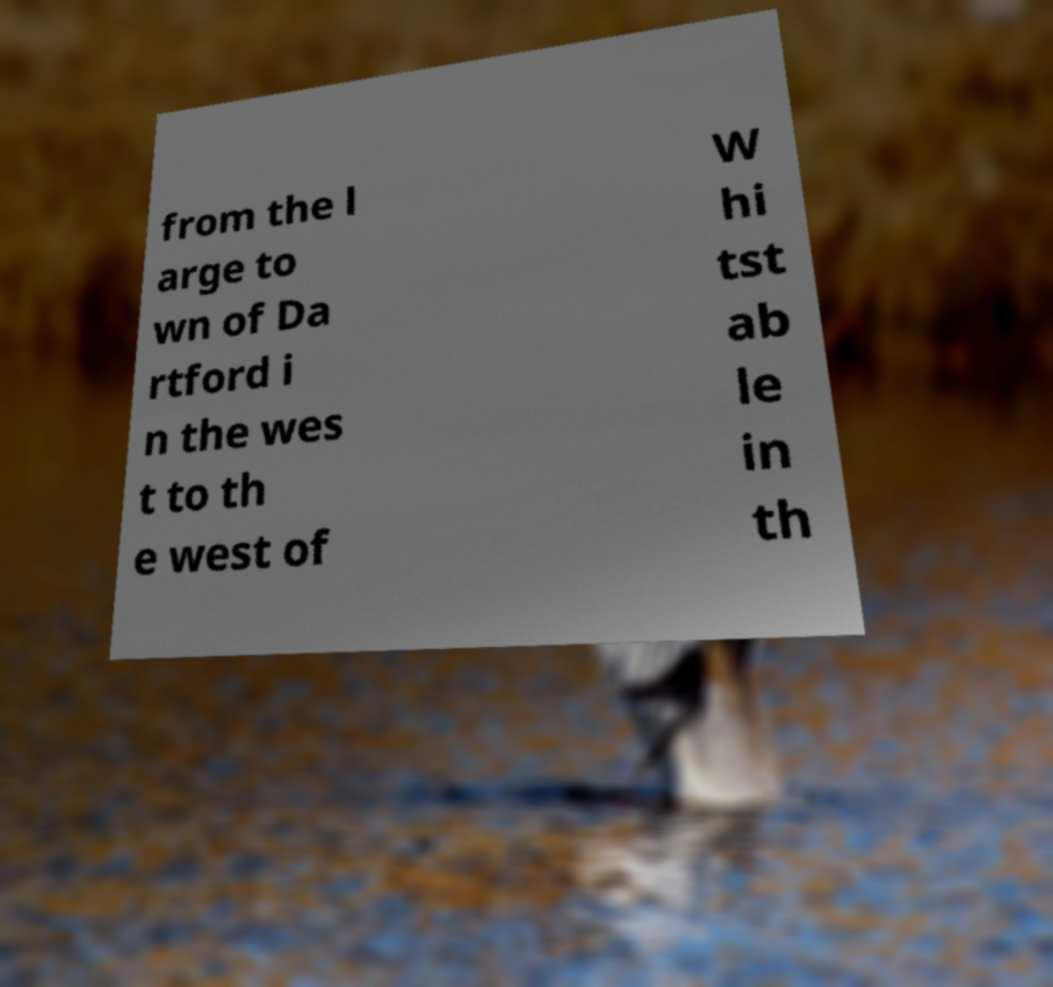There's text embedded in this image that I need extracted. Can you transcribe it verbatim? from the l arge to wn of Da rtford i n the wes t to th e west of W hi tst ab le in th 